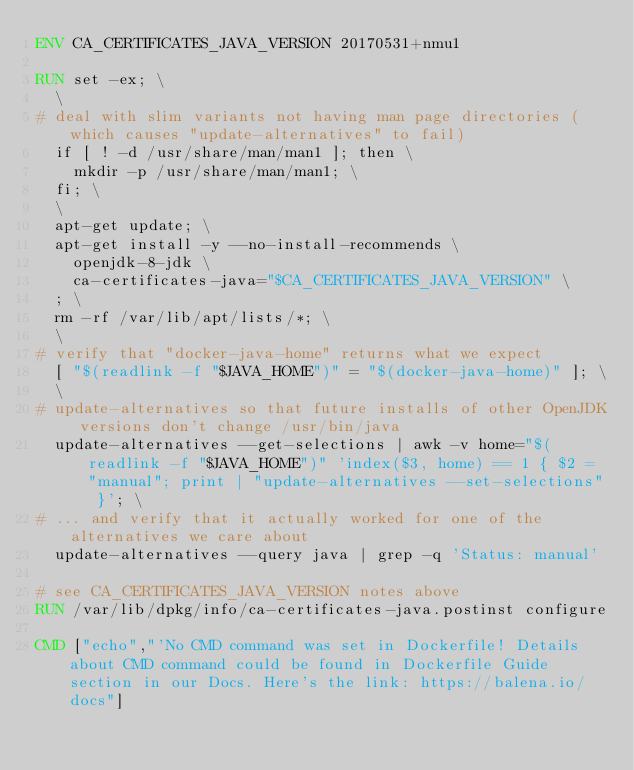Convert code to text. <code><loc_0><loc_0><loc_500><loc_500><_Dockerfile_>ENV CA_CERTIFICATES_JAVA_VERSION 20170531+nmu1

RUN set -ex; \
	\
# deal with slim variants not having man page directories (which causes "update-alternatives" to fail)
	if [ ! -d /usr/share/man/man1 ]; then \
		mkdir -p /usr/share/man/man1; \
	fi; \
	\
	apt-get update; \
	apt-get install -y --no-install-recommends \
		openjdk-8-jdk \
		ca-certificates-java="$CA_CERTIFICATES_JAVA_VERSION" \
	; \
	rm -rf /var/lib/apt/lists/*; \
	\
# verify that "docker-java-home" returns what we expect
	[ "$(readlink -f "$JAVA_HOME")" = "$(docker-java-home)" ]; \
	\
# update-alternatives so that future installs of other OpenJDK versions don't change /usr/bin/java
	update-alternatives --get-selections | awk -v home="$(readlink -f "$JAVA_HOME")" 'index($3, home) == 1 { $2 = "manual"; print | "update-alternatives --set-selections" }'; \
# ... and verify that it actually worked for one of the alternatives we care about
	update-alternatives --query java | grep -q 'Status: manual'

# see CA_CERTIFICATES_JAVA_VERSION notes above
RUN /var/lib/dpkg/info/ca-certificates-java.postinst configure

CMD ["echo","'No CMD command was set in Dockerfile! Details about CMD command could be found in Dockerfile Guide section in our Docs. Here's the link: https://balena.io/docs"]</code> 